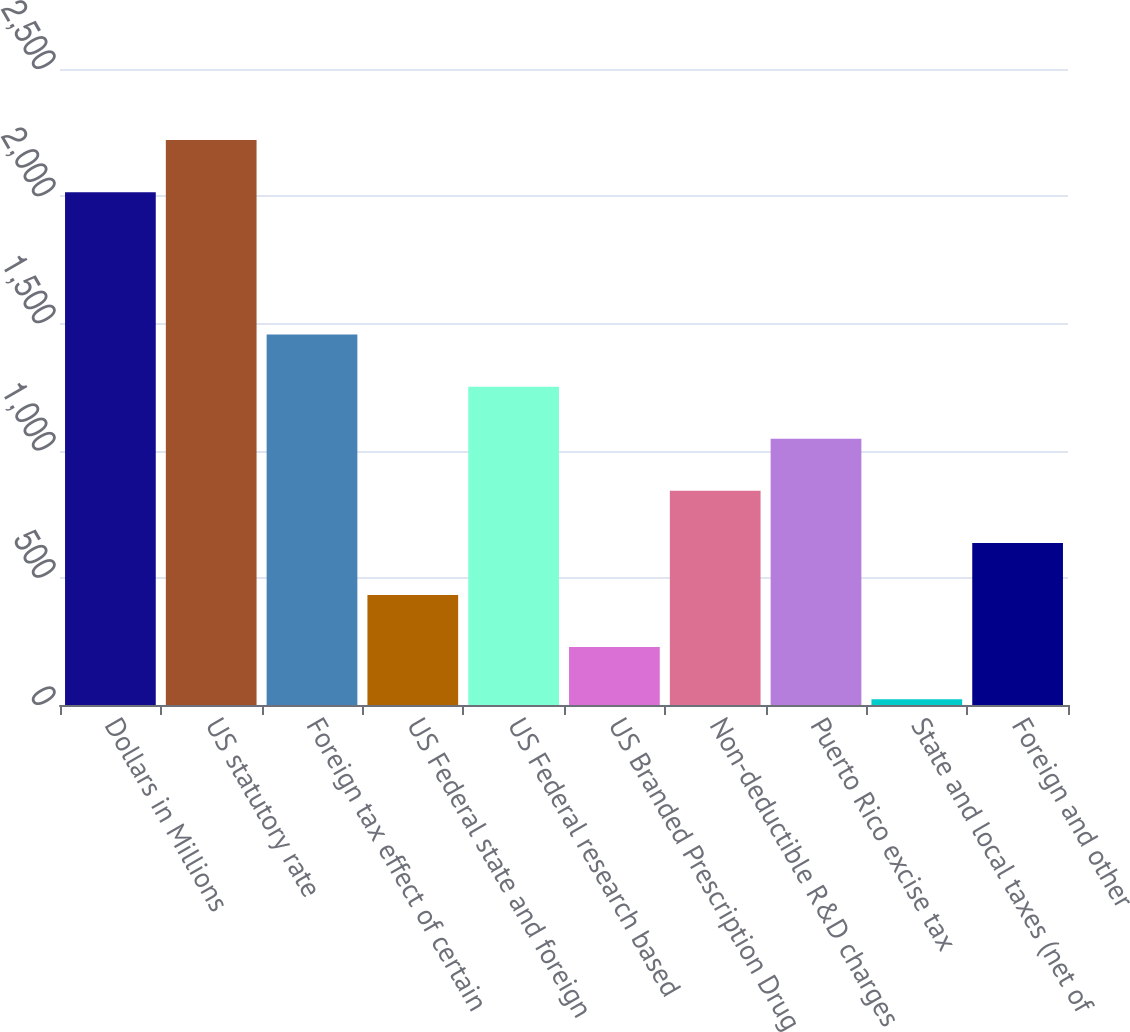Convert chart. <chart><loc_0><loc_0><loc_500><loc_500><bar_chart><fcel>Dollars in Millions<fcel>US statutory rate<fcel>Foreign tax effect of certain<fcel>US Federal state and foreign<fcel>US Federal research based<fcel>US Branded Prescription Drug<fcel>Non-deductible R&D charges<fcel>Puerto Rico excise tax<fcel>State and local taxes (net of<fcel>Foreign and other<nl><fcel>2016<fcel>2220.7<fcel>1455.9<fcel>432.4<fcel>1251.2<fcel>227.7<fcel>841.8<fcel>1046.5<fcel>23<fcel>637.1<nl></chart> 